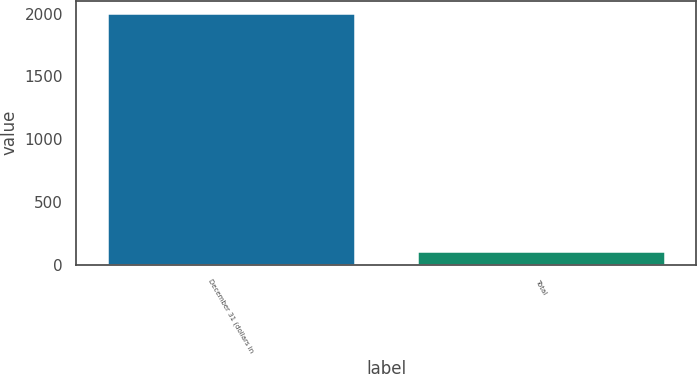<chart> <loc_0><loc_0><loc_500><loc_500><bar_chart><fcel>December 31 (dollars in<fcel>Total<nl><fcel>2004<fcel>113.6<nl></chart> 